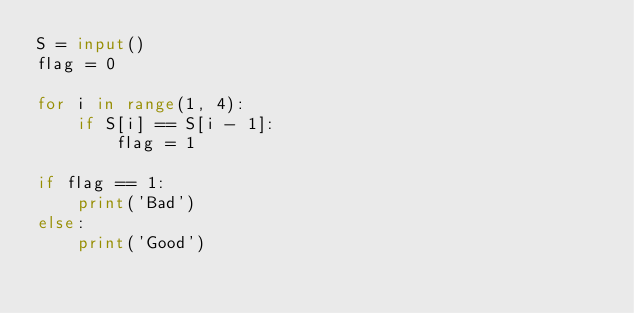<code> <loc_0><loc_0><loc_500><loc_500><_Python_>S = input()
flag = 0

for i in range(1, 4):
	if S[i] == S[i - 1]:
		flag = 1
		
if flag == 1:
	print('Bad')
else:
	print('Good')
	</code> 